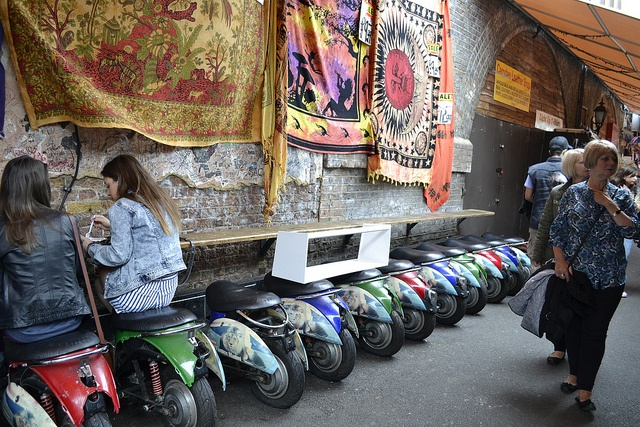Describe the objects in this image and their specific colors. I can see people in maroon, black, and gray tones, people in maroon, black, gray, navy, and darkblue tones, people in maroon, darkgray, black, and lightblue tones, motorcycle in maroon, black, gray, green, and purple tones, and motorcycle in maroon, black, brown, navy, and gray tones in this image. 